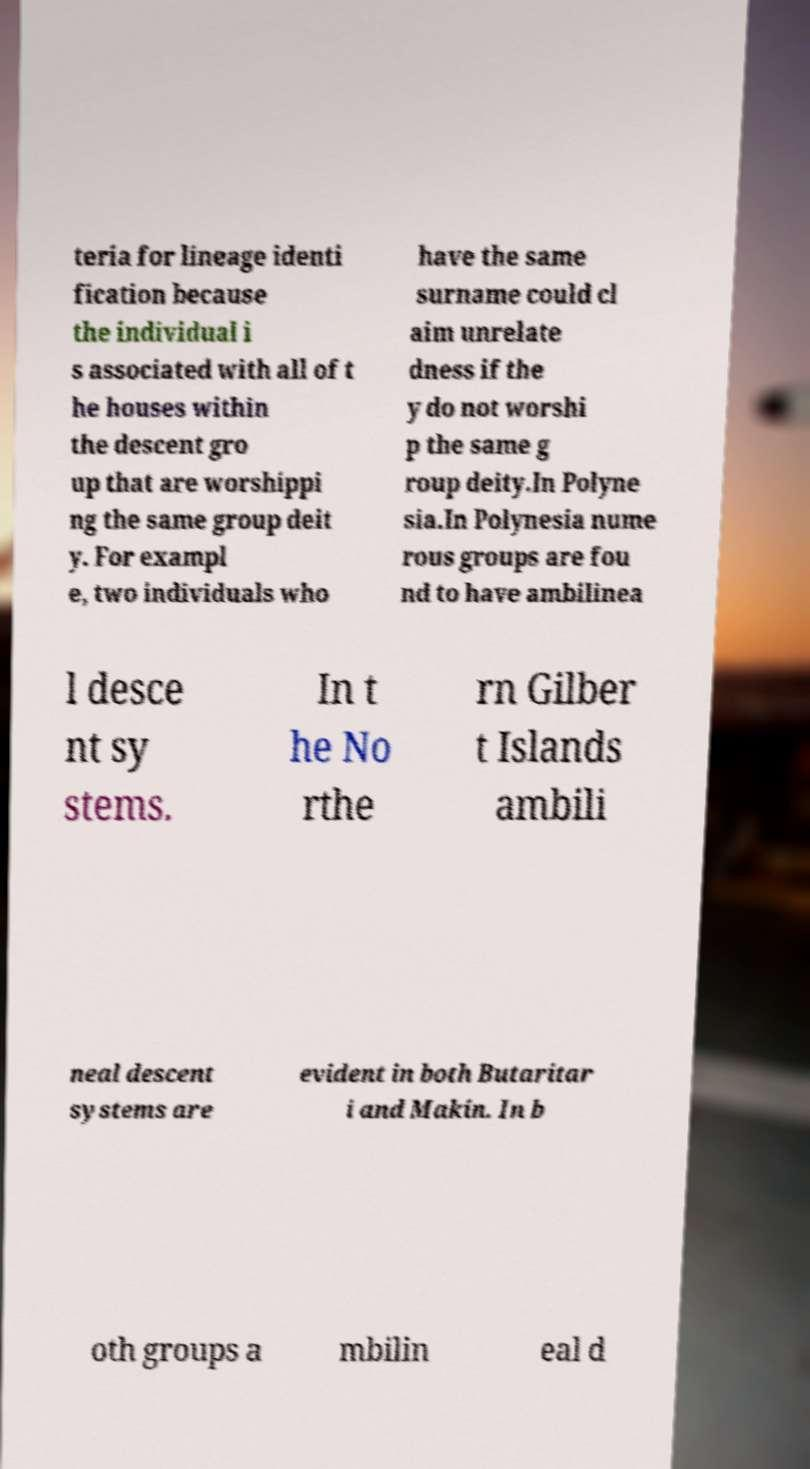Could you assist in decoding the text presented in this image and type it out clearly? teria for lineage identi fication because the individual i s associated with all of t he houses within the descent gro up that are worshippi ng the same group deit y. For exampl e, two individuals who have the same surname could cl aim unrelate dness if the y do not worshi p the same g roup deity.In Polyne sia.In Polynesia nume rous groups are fou nd to have ambilinea l desce nt sy stems. In t he No rthe rn Gilber t Islands ambili neal descent systems are evident in both Butaritar i and Makin. In b oth groups a mbilin eal d 